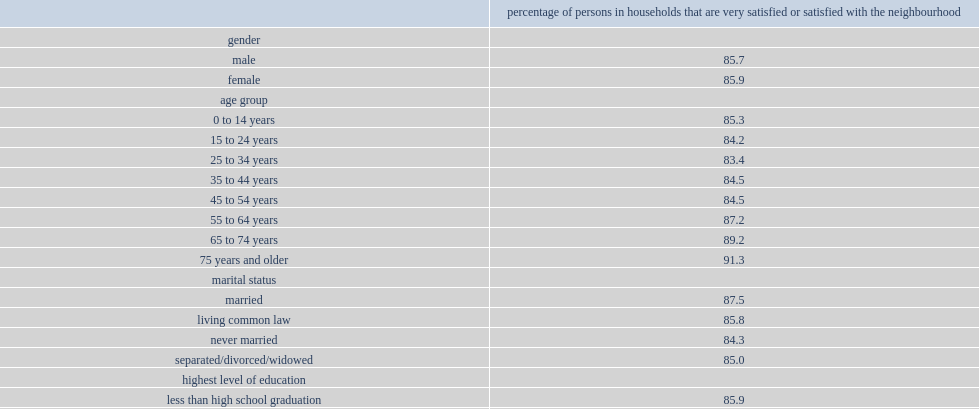Across the different age groups, what was the proportion of households satisfied with their neighbourhood for persons aged 25 to 34 years? 83.4. Across the different age groups, what was the proportion of households satisfied with their neighbourhood for persons aged 75 years and older? 91.3. How many percent of them were in households that are satisfied with their neighbourhood? 79.0. How many percent of visible minorities were in a household that is satisfied with their neighbourhood? 80.8. How many percent of not a visible minorities were in a household that is satisfied with their neighbourhood? 87.6. Parse the full table. {'header': ['', 'percentage of persons in households that are very satisfied or satisfied with the neighbourhood'], 'rows': [['gender', ''], ['male', '85.7'], ['female', '85.9'], ['age group', ''], ['0 to 14 years', '85.3'], ['15 to 24 years', '84.2'], ['25 to 34 years', '83.4'], ['35 to 44 years', '84.5'], ['45 to 54 years', '84.5'], ['55 to 64 years', '87.2'], ['65 to 74 years', '89.2'], ['75 years and older', '91.3'], ['marital status', ''], ['married', '87.5'], ['living common law', '85.8'], ['never married', '84.3'], ['separated/divorced/widowed', '85.0'], ['highest level of education', ''], ['less than high school graduation', '85.9'], ['high school diploma or equivalent', '85.3'], ['apprenticeship or trades certificate or diploma and college, cegep or other non-university certificate or diploma', '85.5'], ['university certificate, diploma or degree', '86.5'], ['main activity in the last 12 months', ''], ['working at a paid job or self-employed', '85.7'], ['looking for job', '79.0'], ['going to school', '84.0'], ['keeping house, caring for other family members', '85.0'], ['retired', '90.1'], ['other', '81.7'], ['visible minority', ''], ['visible minority', '80.8'], ['not a visible minority', '87.6'], ['aboriginal identity', ''], ['aboriginal', '84.3'], ['non-aboriginal', '85.8'], ['veteran status', ''], ['veteran', '87.7'], ['currently a member of the canadian armed forces', '84.7'], ['never had canadian military service', '85.8']]} 